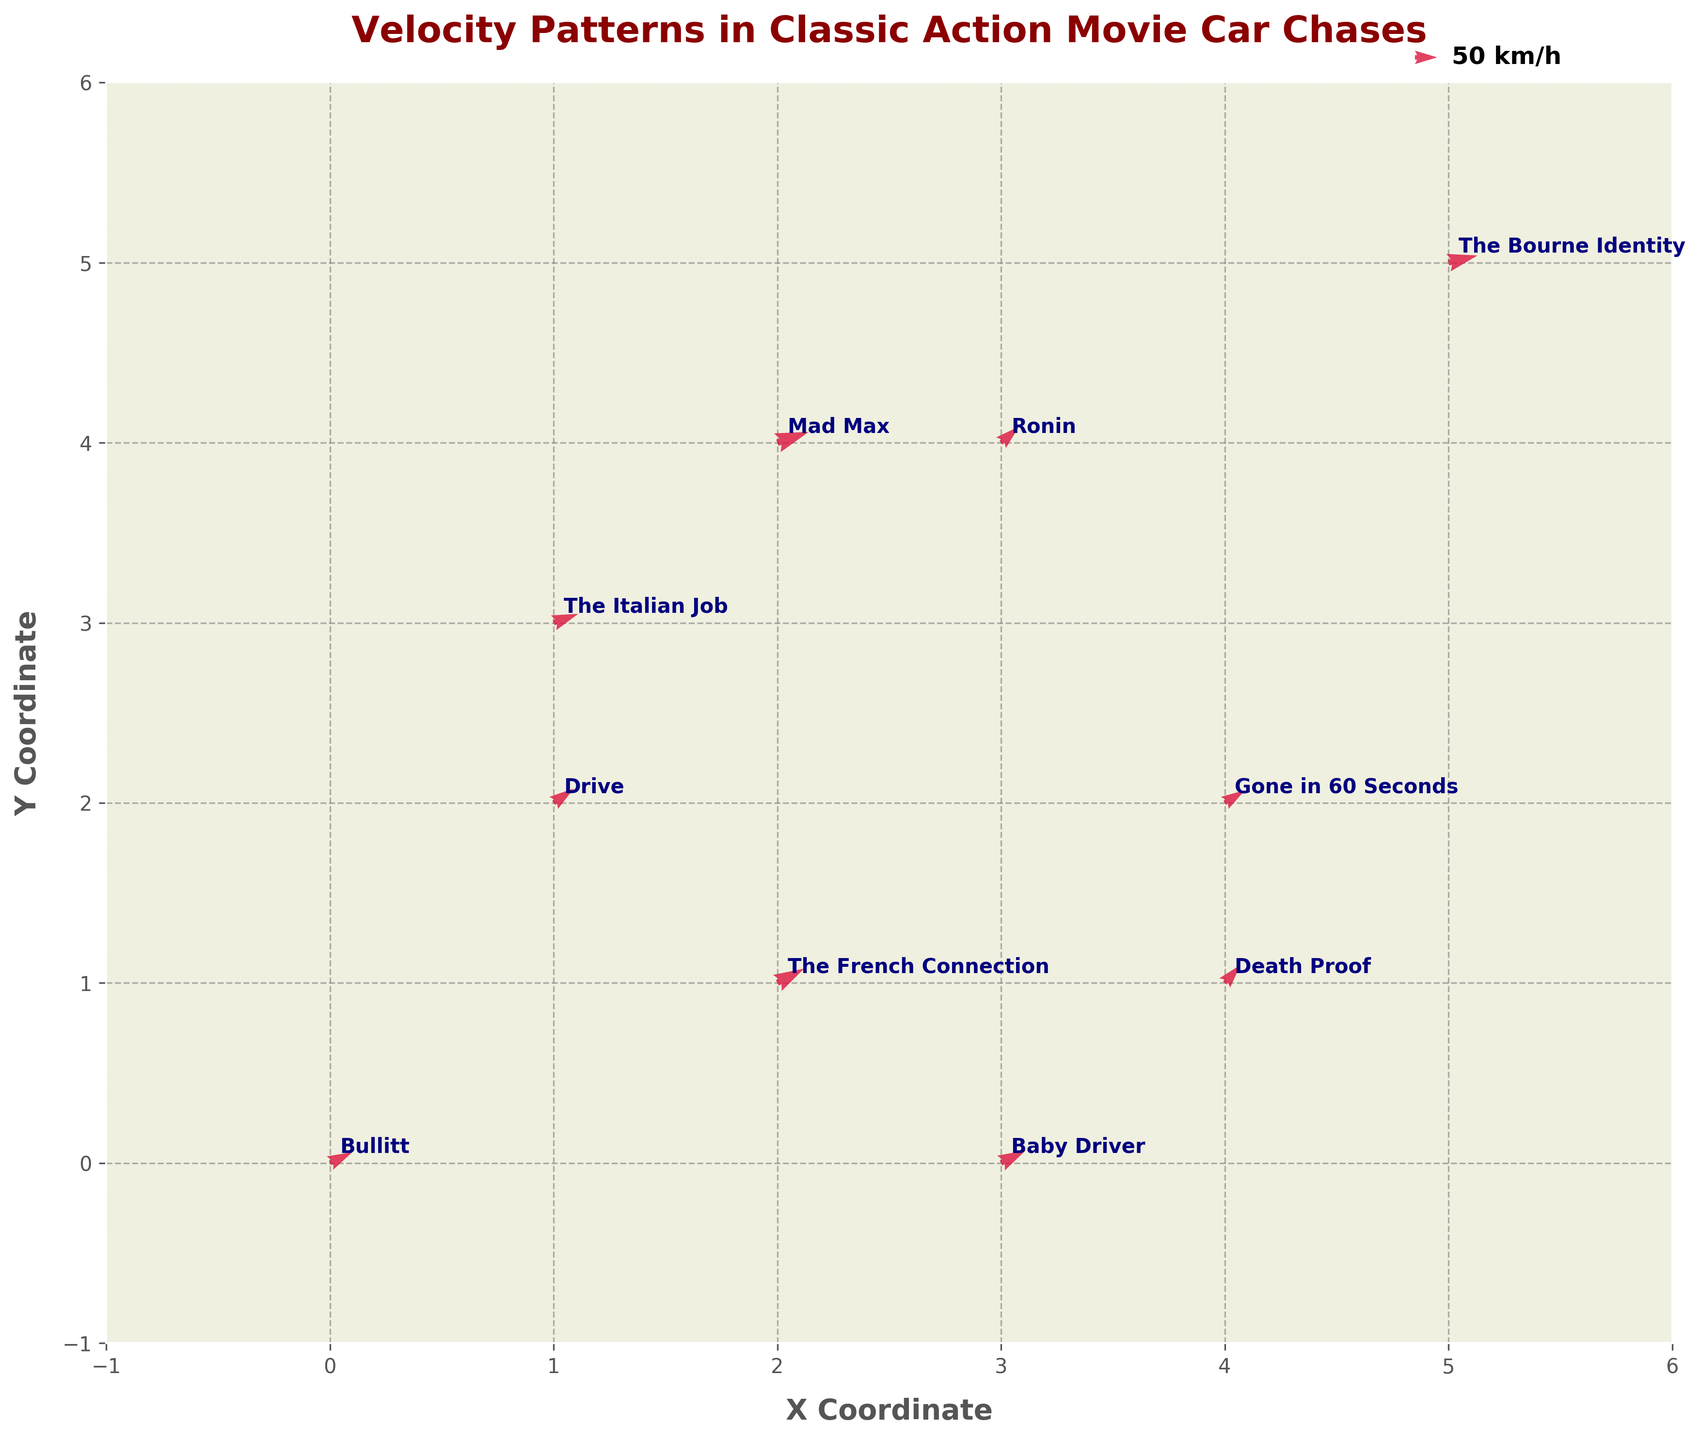What is the title of the figure? The title is usually displayed prominently at the top of the figure in bold and large font. In this case, the title is clearly written as "Velocity Patterns in Classic Action Movie Car Chases".
Answer: Velocity Patterns in Classic Action Movie Car Chases What colors are used for the quiver arrows? The quiver arrows' colors are mentioned to be 'crimson' which is a shade of red. This can be visually confirmed by looking at the arrows in the plot which appear in a deep red color.
Answer: Crimson Which movie has the highest combined velocity (u+v)? To find the highest combined velocity, add the 'u' and 'v' values for each movie and compare them. The highest combined velocity is for "Mad Max" with u=70 and v=30, giving a total of 70+30=100.
Answer: Mad Max Which movies have car chase vectors pointing towards the positive Y direction? To determine this, check the 'v' component of the velocity vectors. A positive 'v' indicates direction towards the positive Y axis. The movies with positive 'v' values are "Bullitt", "The French Connection", "Gone in 60 Seconds", "Death Proof", "Drive", and "Baby Driver".
Answer: Bullitt, The French Connection, Gone in 60 Seconds, Death Proof, Drive, Baby Driver Which movie is located at the coordinates (3, 4)? The coordinates of each movie are given in the dataset, and we can match the coordinates (3,4) to the movie "Ronin".
Answer: Ronin What is the direction of the velocity vector of "The Italian Job"? The direction can be determined by looking at the 'u' and 'v' components. For "The Italian Job", u=55 and v=25. This direction is roughly towards the positive X and Y axes.
Answer: Positive X and Y directions Compare the velocity vectors of "The Bourne Identity" and "Drive". Which one is longer? Calculate the magnitudes of the velocity vectors using the formula √(u²+v²). For "The Bourne Identity", the length is √(65²+20²) which is about 68.38. For "Drive", the length is √(45²+40²) which is about 60.21. "The Bourne Identity" has a longer vector.
Answer: The Bourne Identity Calculate the average 'u' value of all movies displayed. Sum up the 'u' values (50+60+45+55+40+65+70+35+45+55=520) and divide by the number of movies (10), giving an average of 520/10 = 52.
Answer: 52 Which movies have their car chase vectors pointing predominantly towards the positive X direction? Check for the 'u' values to determine the predominance in the positive X direction. The movies with positive 'u' values are all listed, but "Mad Max" with u=70 is highly dominant.
Answer: All listed; Mad Max most dominant 